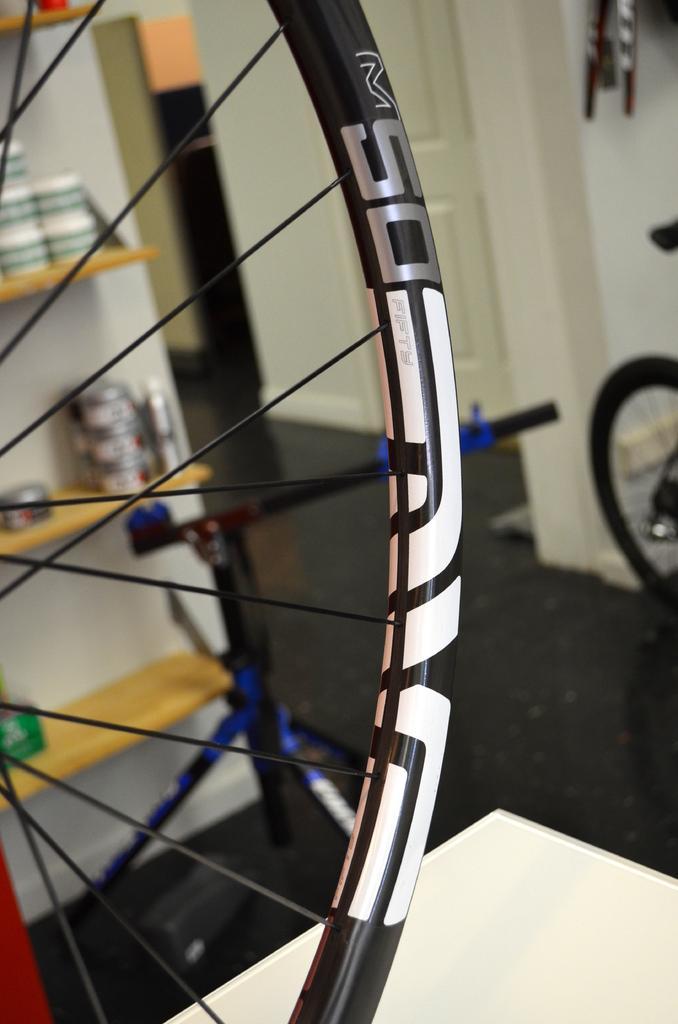Please provide a concise description of this image. In this image in the foreground there is one wheel, and in the background there is one cupboard. In that cupboard there are some cups and some objects, and in the background there is a door and wall. On the right side there is one wheel, at the bottom there is a floor and one board. 